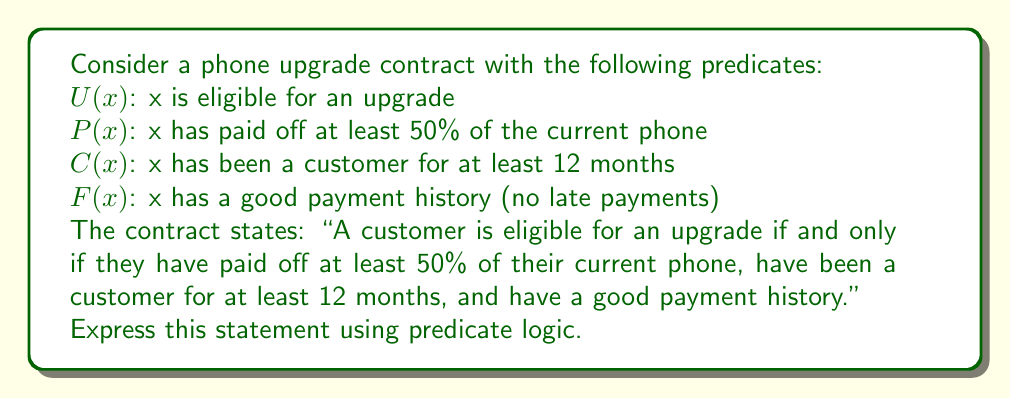Show me your answer to this math problem. To express the given statement using predicate logic, we need to break it down and translate each part into logical symbols:

1. "A customer is eligible for an upgrade if and only if..." 
   This is a biconditional statement, which we represent with $\leftrightarrow$.

2. "...they have paid off at least 50% of their current phone..."
   This is represented by $P(x)$.

3. "...have been a customer for at least 12 months..."
   This is represented by $C(x)$.

4. "...and have a good payment history."
   This is represented by $F(x)$.

5. The "and" connecting these conditions is represented by $\wedge$.

Putting it all together, we get:

$$U(x) \leftrightarrow (P(x) \wedge C(x) \wedge F(x))$$

This logical statement reads as: "For any customer x, x is eligible for an upgrade if and only if x has paid off at least 50% of their current phone, and x has been a customer for at least 12 months, and x has a good payment history."

The biconditional ($\leftrightarrow$) ensures that the eligibility is both necessary and sufficient - that is, if a customer is eligible, they must satisfy all these conditions, and if they satisfy all these conditions, they must be eligible.
Answer: $$U(x) \leftrightarrow (P(x) \wedge C(x) \wedge F(x))$$ 